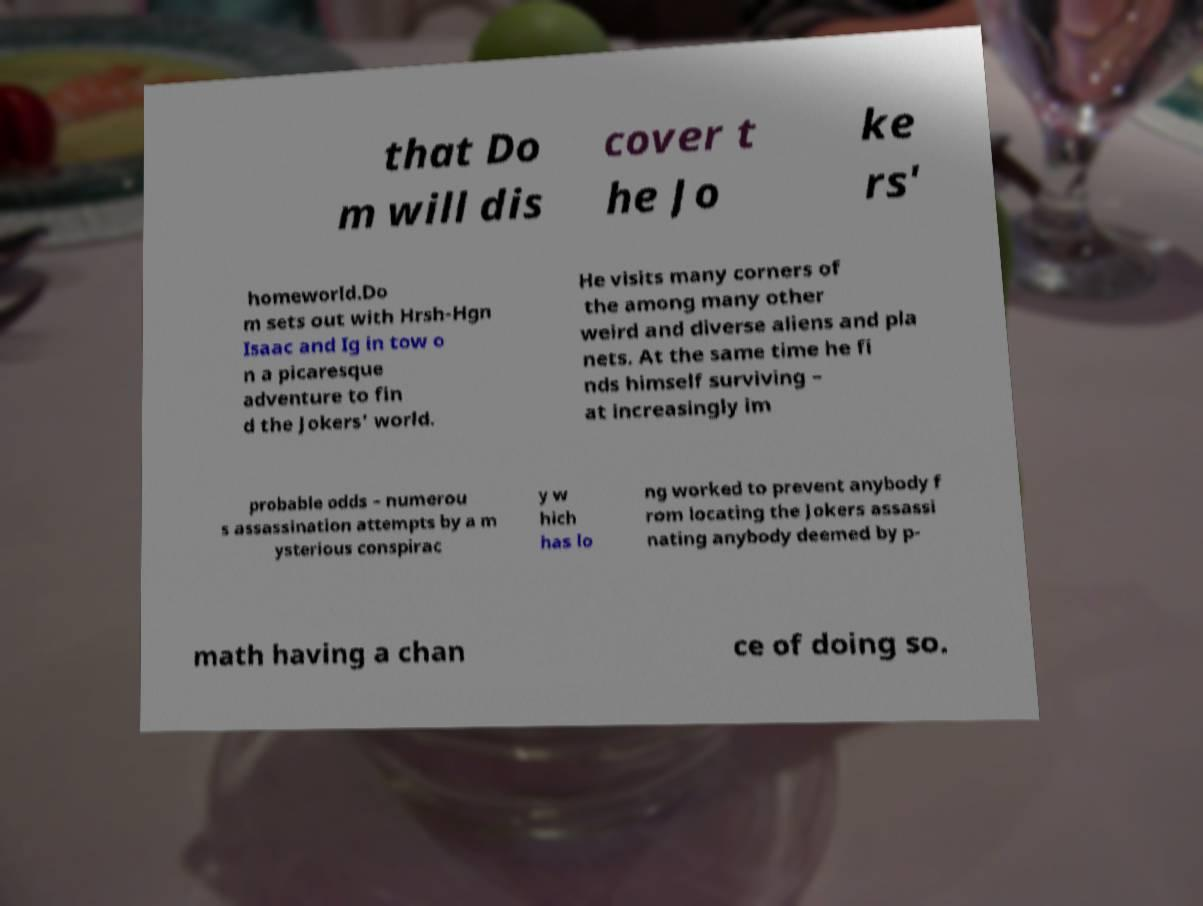For documentation purposes, I need the text within this image transcribed. Could you provide that? that Do m will dis cover t he Jo ke rs' homeworld.Do m sets out with Hrsh-Hgn Isaac and Ig in tow o n a picaresque adventure to fin d the Jokers' world. He visits many corners of the among many other weird and diverse aliens and pla nets. At the same time he fi nds himself surviving – at increasingly im probable odds – numerou s assassination attempts by a m ysterious conspirac y w hich has lo ng worked to prevent anybody f rom locating the Jokers assassi nating anybody deemed by p- math having a chan ce of doing so. 